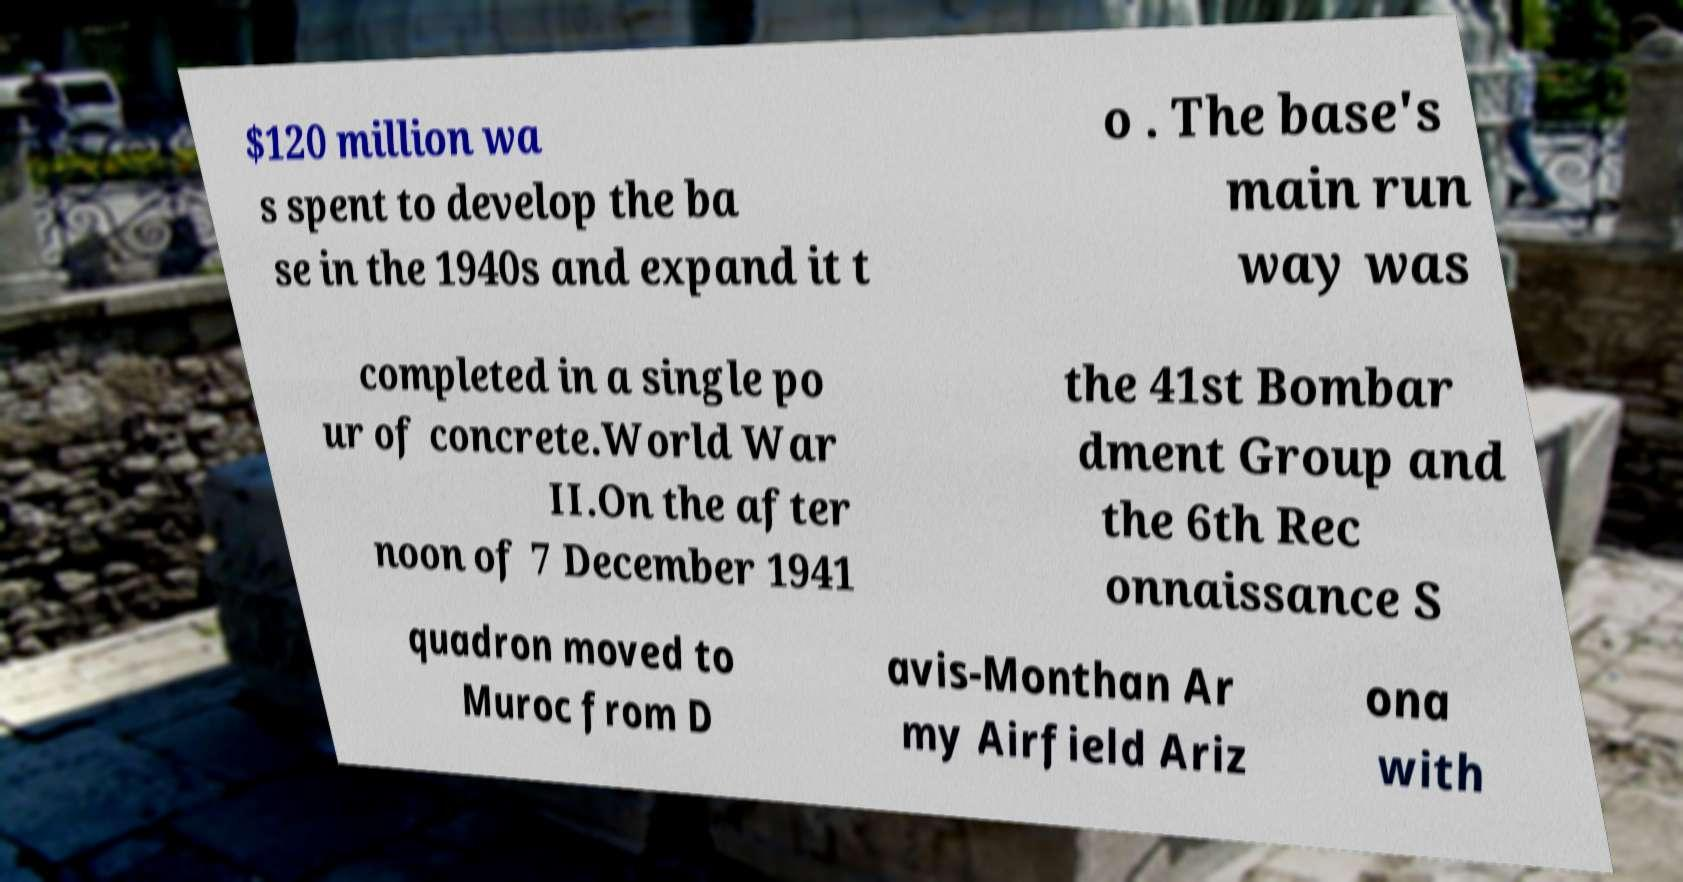Could you assist in decoding the text presented in this image and type it out clearly? $120 million wa s spent to develop the ba se in the 1940s and expand it t o . The base's main run way was completed in a single po ur of concrete.World War II.On the after noon of 7 December 1941 the 41st Bombar dment Group and the 6th Rec onnaissance S quadron moved to Muroc from D avis-Monthan Ar my Airfield Ariz ona with 